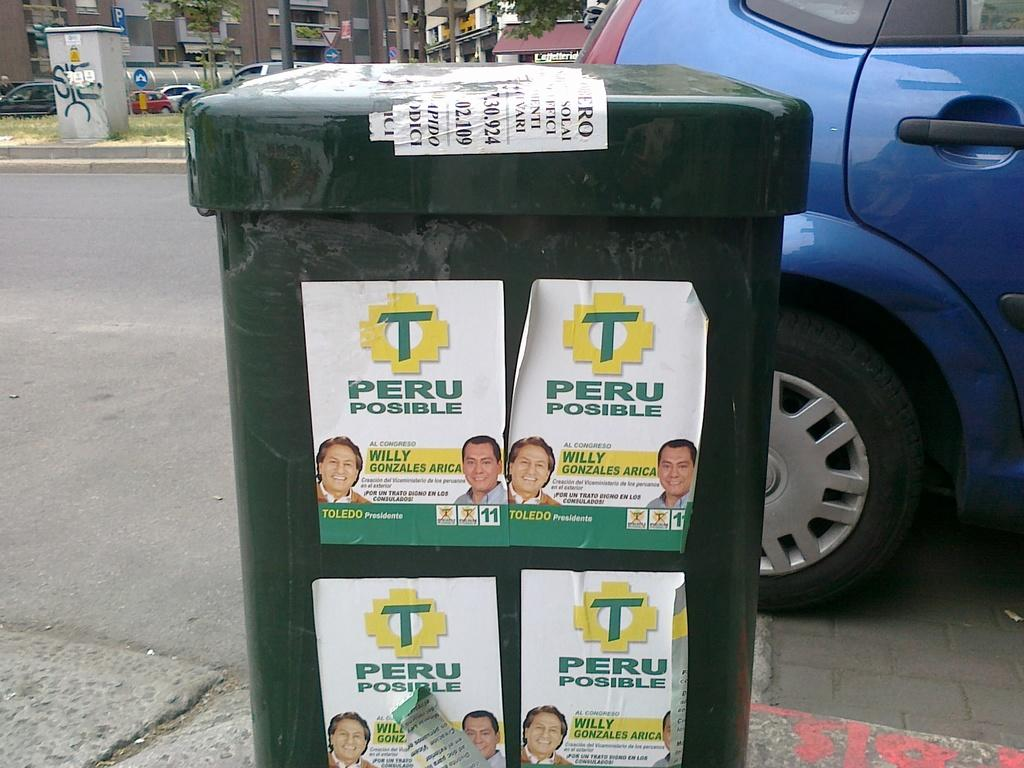Provide a one-sentence caption for the provided image. Several Peru Possible posters on a green trash can on the street. 